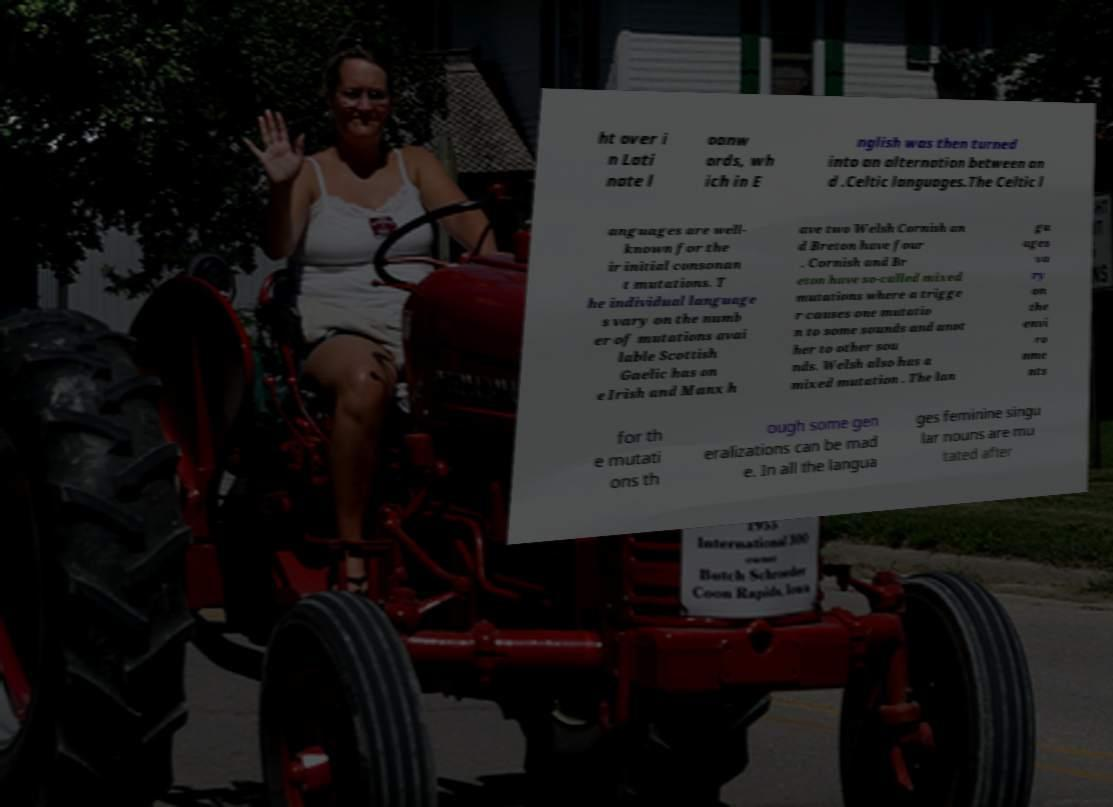Could you assist in decoding the text presented in this image and type it out clearly? ht over i n Lati nate l oanw ords, wh ich in E nglish was then turned into an alternation between an d .Celtic languages.The Celtic l anguages are well- known for the ir initial consonan t mutations. T he individual language s vary on the numb er of mutations avai lable Scottish Gaelic has on e Irish and Manx h ave two Welsh Cornish an d Breton have four . Cornish and Br eton have so-called mixed mutations where a trigge r causes one mutatio n to some sounds and anot her to other sou nds. Welsh also has a mixed mutation . The lan gu ages va ry on the envi ro nme nts for th e mutati ons th ough some gen eralizations can be mad e. In all the langua ges feminine singu lar nouns are mu tated after 